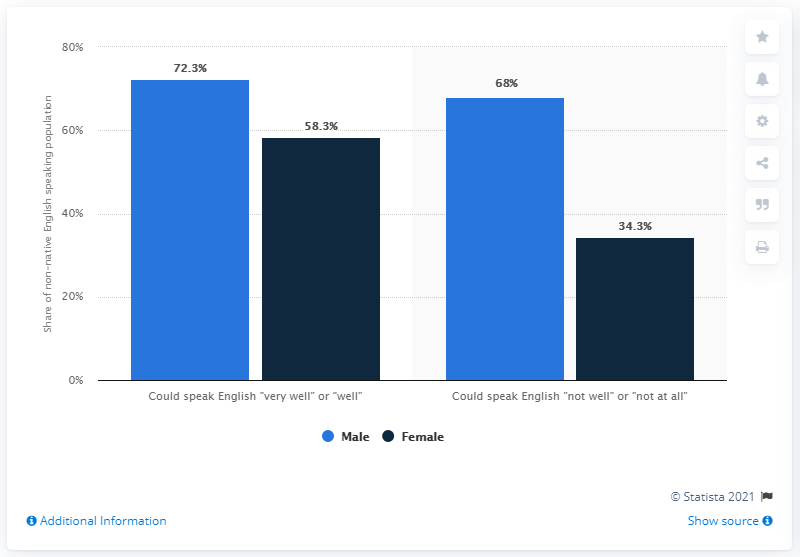Outline some significant characteristics in this image. The light blue bars represent male gender. The English language proficiency that leads to a larger gender difference is the ability to speak English "not well" or "not at all. 